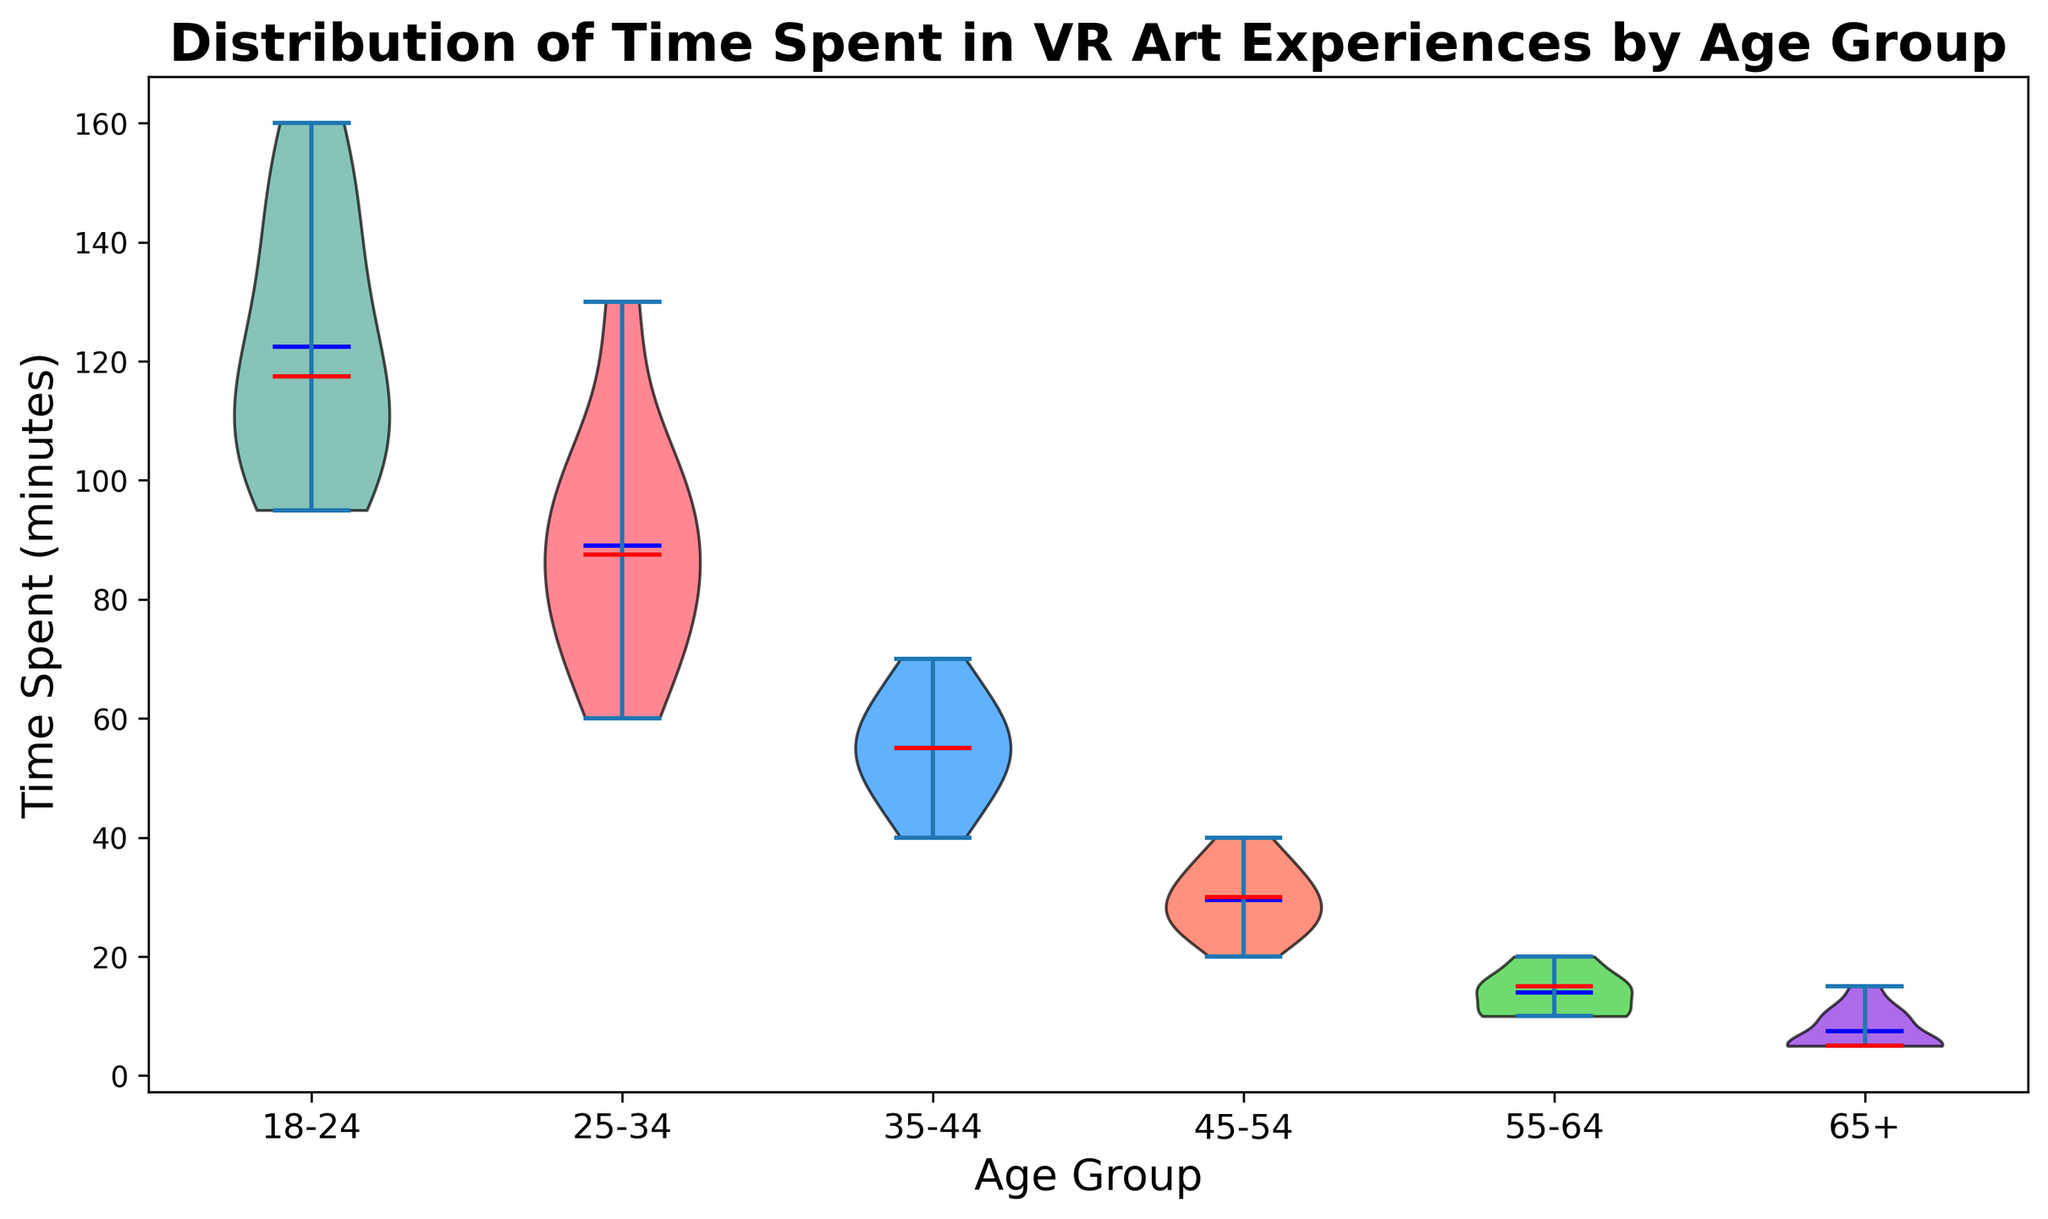What's the median time spent in VR art experiences for the 18-24 age group? To determine the median time spent for the 18-24 age group, look at the red line within the violin shape for this group. The red line inside the violin plot represents the median value.
Answer: 115 minutes Which age group has the highest average time spent in VR art experiences? The average time spent is represented by the blue line within each violin shape. The 18-24 age group has the highest blue line, indicating the highest mean or average time spent.
Answer: 18-24 Compare the spread of time spent in VR between the 25-34 and 35-44 age groups. Which one is more spread out? The spread of the data can be observed by the width of the violin plot. The 25-34 age group's violin is wider than the 35-44 age group's violin, indicating a larger spread of data.
Answer: 25-34 What is the range of time spent in VR for the 55-64 age group? The range is determined by looking at the extremes of the violin plot for the 55-64 age group; it extends from the lowest point to the highest point of the shaded area. The lower end is 10 minutes and the upper end is 20 minutes.
Answer: 10 to 20 minutes Is there a significant overlap in the time distributions between the 35-44 and 45-54 age groups? By comparing the violins for the 35-44 and 45-54 age groups, look at how much they overlap horizontally. There is significant overlap indicating similar distributions.
Answer: Yes What age group spends the least amount of time in VR art experiences on average? Identify the age group with the lowest blue line, which represents the mean time spent. The 65+ age group has the lowest mean time spent.
Answer: 65+ Compare the median time spent in VR between the 35-44 and 45-54 age groups. Which one is higher? The red lines inside the violins for 35-44 and 45-54 indicate their respective medians. The 35-44 group has a higher red line compared to the 45-54 group.
Answer: 35-44 Describe the visual difference in the distributions of the 18-24 and 65+ age groups. The 18-24 age group has a much wider and taller violin plot compared to the relatively narrow and short violin for the 65+ age group, indicating a much larger spread and higher range of time spent in VR experiences.
Answer: 18-24 has a wider distribution Which age group shows the smallest spread in the time spent in VR art experiences? The smallest spread of data is indicated by the narrowest violin plot. The 65+ age group has the narrowest violin, indicating the smallest spread in time spent.
Answer: 65+ 